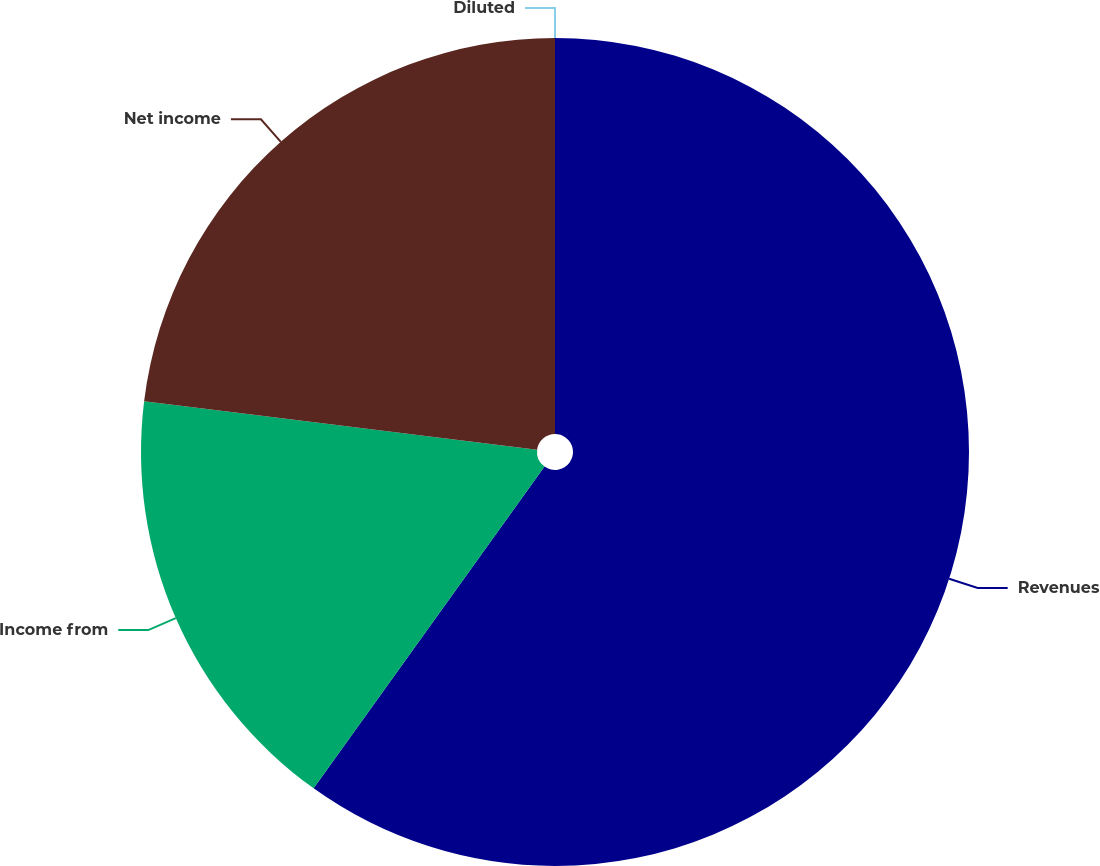<chart> <loc_0><loc_0><loc_500><loc_500><pie_chart><fcel>Revenues<fcel>Income from<fcel>Net income<fcel>Diluted<nl><fcel>59.9%<fcel>17.05%<fcel>23.04%<fcel>0.0%<nl></chart> 